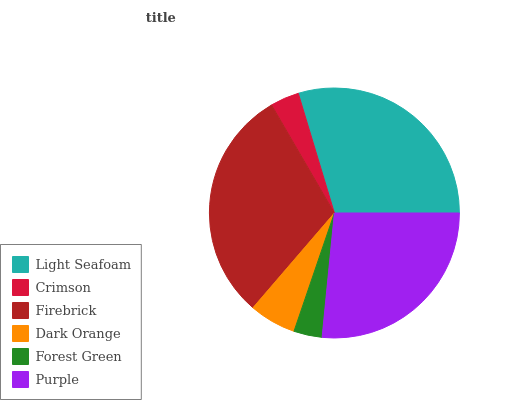Is Forest Green the minimum?
Answer yes or no. Yes. Is Firebrick the maximum?
Answer yes or no. Yes. Is Crimson the minimum?
Answer yes or no. No. Is Crimson the maximum?
Answer yes or no. No. Is Light Seafoam greater than Crimson?
Answer yes or no. Yes. Is Crimson less than Light Seafoam?
Answer yes or no. Yes. Is Crimson greater than Light Seafoam?
Answer yes or no. No. Is Light Seafoam less than Crimson?
Answer yes or no. No. Is Purple the high median?
Answer yes or no. Yes. Is Dark Orange the low median?
Answer yes or no. Yes. Is Forest Green the high median?
Answer yes or no. No. Is Light Seafoam the low median?
Answer yes or no. No. 